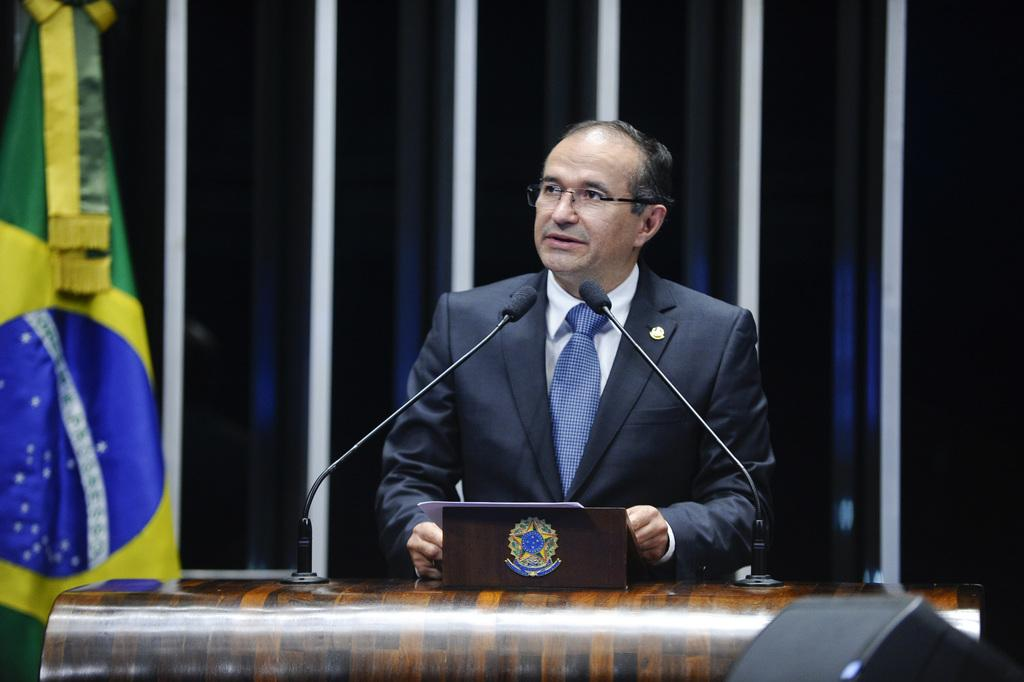Who or what is present in the image? There is a person in the image. What is in front of the person? There is a table in front of the person. What objects are on the table? There are microphones on the table. What type of organization is responsible for the mine in the image? There is no mine present in the image, so it is not possible to determine which organization might be responsible for it. 